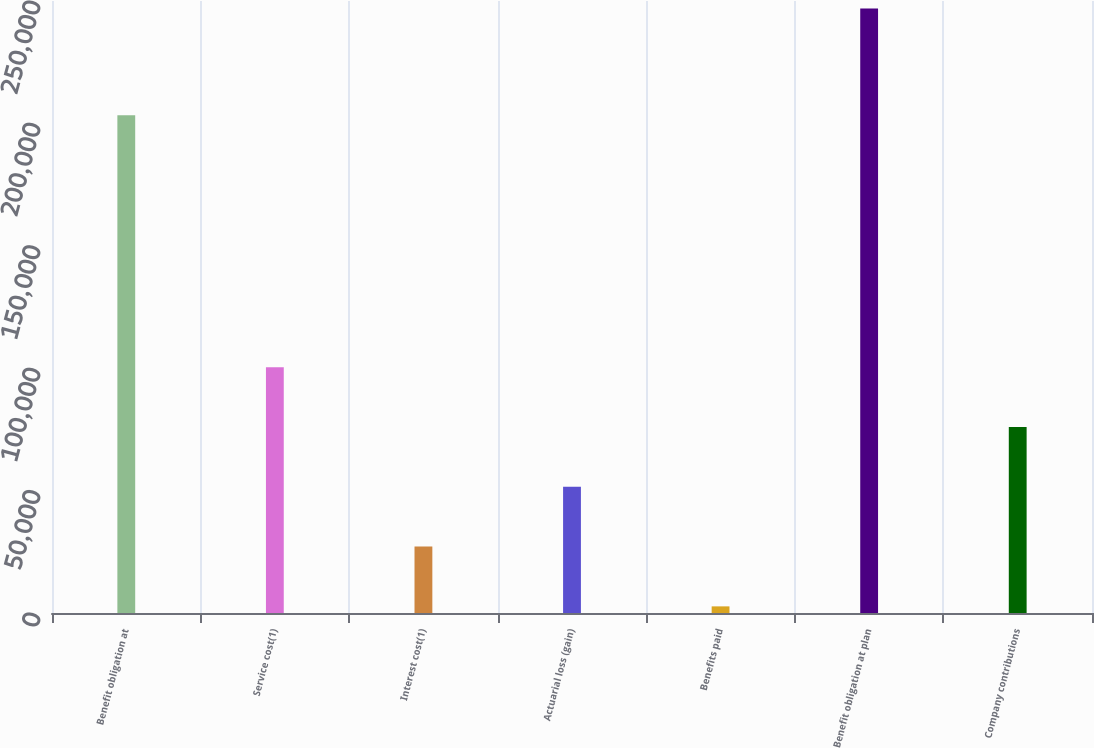<chart> <loc_0><loc_0><loc_500><loc_500><bar_chart><fcel>Benefit obligation at<fcel>Service cost(1)<fcel>Interest cost(1)<fcel>Actuarial loss (gain)<fcel>Benefits paid<fcel>Benefit obligation at plan<fcel>Company contributions<nl><fcel>203292<fcel>100416<fcel>27131.2<fcel>51559.4<fcel>2703<fcel>246985<fcel>75987.6<nl></chart> 